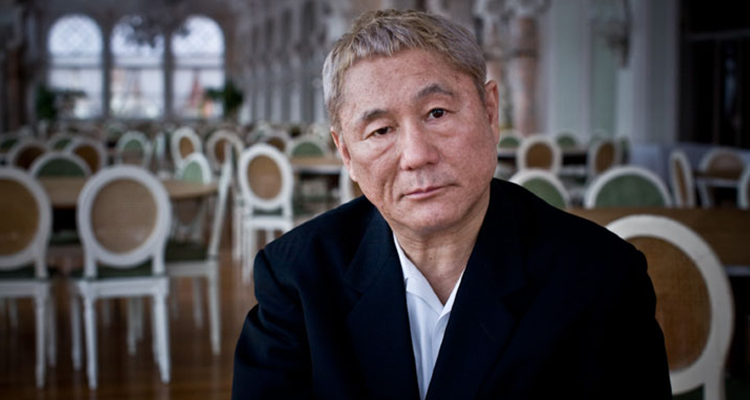Describe the potential significance of the setting in relation to the main subject of the image? The setting of an opulent restaurant with its ornate interior and pristine layout serves as a stark, yet complementary backdrop to the solemn figure. It hints at a narrative where the setting might represent a place of social gathering or important meetings, juxtaposing the individual's isolation and contemplative state, suggesting a scenario of prior or forthcoming significant events. 